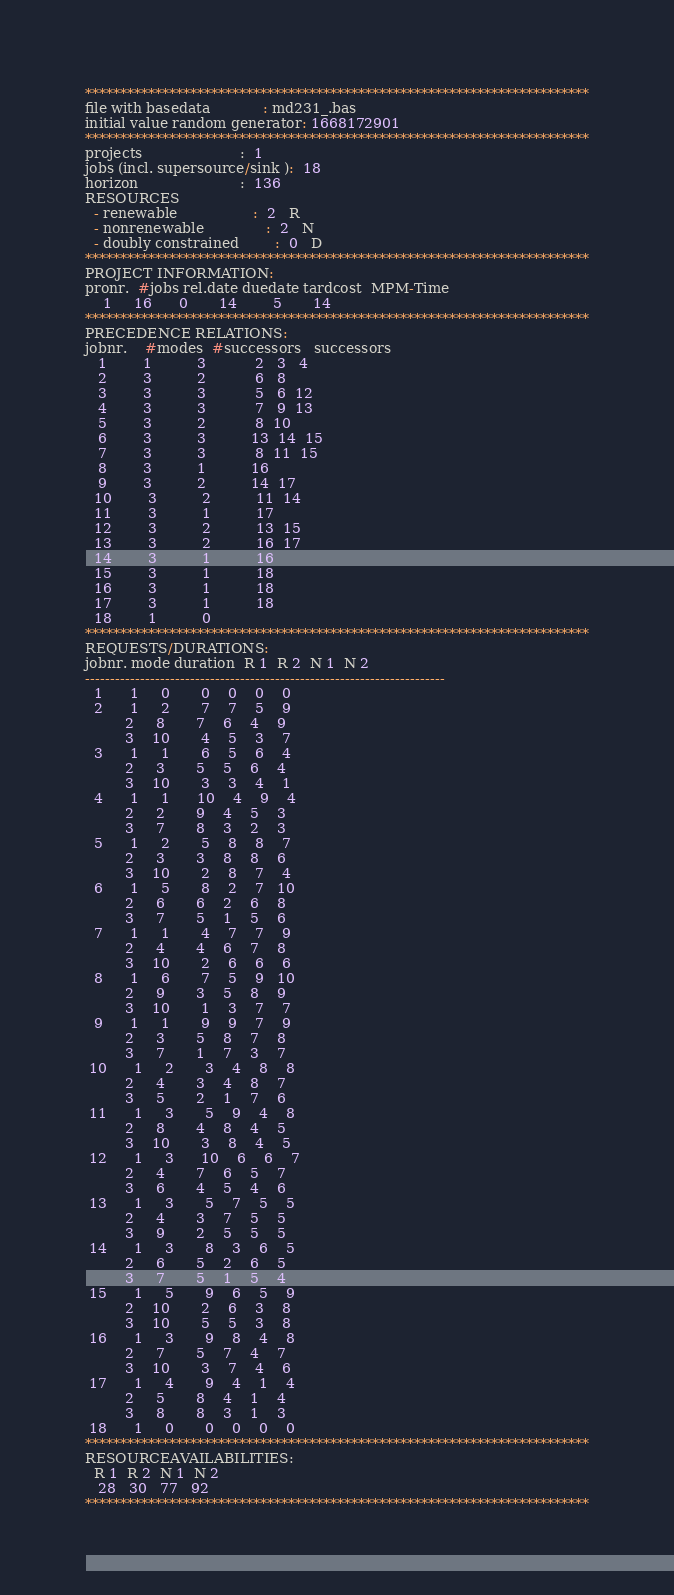Convert code to text. <code><loc_0><loc_0><loc_500><loc_500><_ObjectiveC_>************************************************************************
file with basedata            : md231_.bas
initial value random generator: 1668172901
************************************************************************
projects                      :  1
jobs (incl. supersource/sink ):  18
horizon                       :  136
RESOURCES
  - renewable                 :  2   R
  - nonrenewable              :  2   N
  - doubly constrained        :  0   D
************************************************************************
PROJECT INFORMATION:
pronr.  #jobs rel.date duedate tardcost  MPM-Time
    1     16      0       14        5       14
************************************************************************
PRECEDENCE RELATIONS:
jobnr.    #modes  #successors   successors
   1        1          3           2   3   4
   2        3          2           6   8
   3        3          3           5   6  12
   4        3          3           7   9  13
   5        3          2           8  10
   6        3          3          13  14  15
   7        3          3           8  11  15
   8        3          1          16
   9        3          2          14  17
  10        3          2          11  14
  11        3          1          17
  12        3          2          13  15
  13        3          2          16  17
  14        3          1          16
  15        3          1          18
  16        3          1          18
  17        3          1          18
  18        1          0        
************************************************************************
REQUESTS/DURATIONS:
jobnr. mode duration  R 1  R 2  N 1  N 2
------------------------------------------------------------------------
  1      1     0       0    0    0    0
  2      1     2       7    7    5    9
         2     8       7    6    4    9
         3    10       4    5    3    7
  3      1     1       6    5    6    4
         2     3       5    5    6    4
         3    10       3    3    4    1
  4      1     1      10    4    9    4
         2     2       9    4    5    3
         3     7       8    3    2    3
  5      1     2       5    8    8    7
         2     3       3    8    8    6
         3    10       2    8    7    4
  6      1     5       8    2    7   10
         2     6       6    2    6    8
         3     7       5    1    5    6
  7      1     1       4    7    7    9
         2     4       4    6    7    8
         3    10       2    6    6    6
  8      1     6       7    5    9   10
         2     9       3    5    8    9
         3    10       1    3    7    7
  9      1     1       9    9    7    9
         2     3       5    8    7    8
         3     7       1    7    3    7
 10      1     2       3    4    8    8
         2     4       3    4    8    7
         3     5       2    1    7    6
 11      1     3       5    9    4    8
         2     8       4    8    4    5
         3    10       3    8    4    5
 12      1     3      10    6    6    7
         2     4       7    6    5    7
         3     6       4    5    4    6
 13      1     3       5    7    5    5
         2     4       3    7    5    5
         3     9       2    5    5    5
 14      1     3       8    3    6    5
         2     6       5    2    6    5
         3     7       5    1    5    4
 15      1     5       9    6    5    9
         2    10       2    6    3    8
         3    10       5    5    3    8
 16      1     3       9    8    4    8
         2     7       5    7    4    7
         3    10       3    7    4    6
 17      1     4       9    4    1    4
         2     5       8    4    1    4
         3     8       8    3    1    3
 18      1     0       0    0    0    0
************************************************************************
RESOURCEAVAILABILITIES:
  R 1  R 2  N 1  N 2
   28   30   77   92
************************************************************************
</code> 